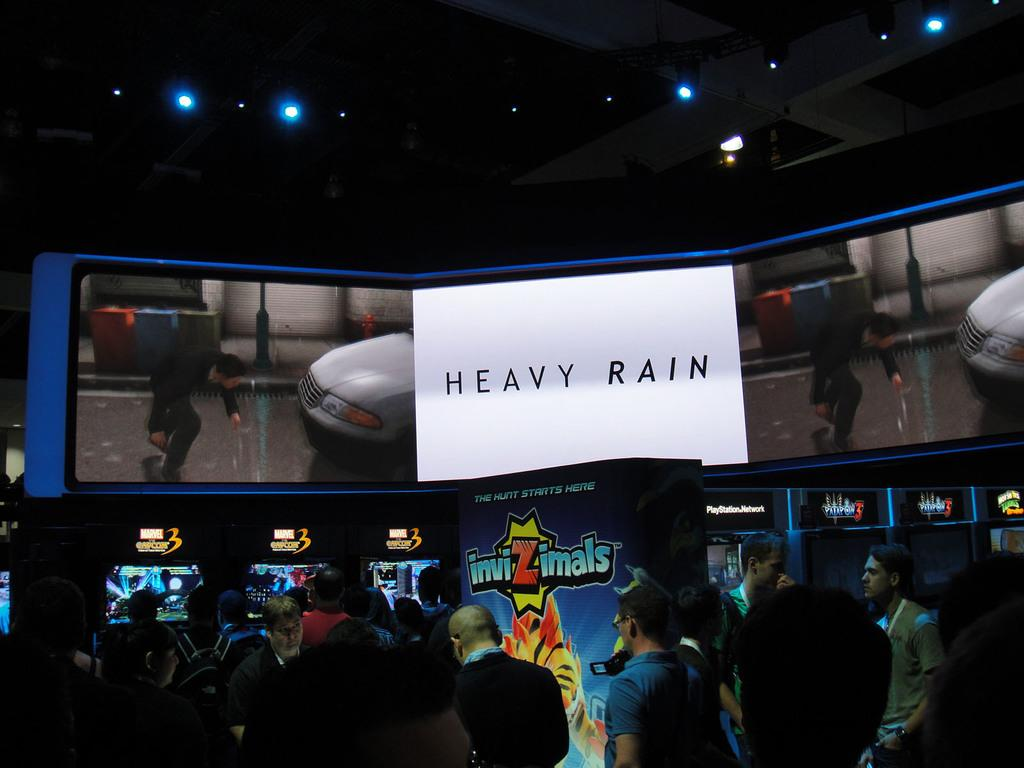How many people are in the image? There is a group of people in the image, but the exact number cannot be determined from the provided facts. What can be seen in the background of the image? There are lights visible in the background of the image. What type of jeans are the people wearing in the image? There is no information about the type of jeans the people are wearing in the image, as the provided facts do not mention clothing. 